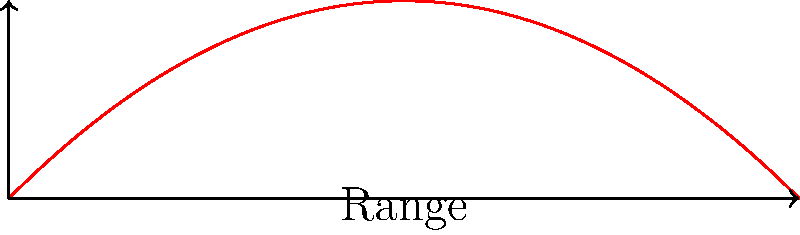In "The Hammer's Edge," Larry "Animal" Garner describes a scene where the protagonist throws a knife with an initial velocity of 20 m/s at a 45° angle. Using the provided diagram, calculate the maximum range of the thrown knife. Assume the knife is thrown from ground level and neglect air resistance. To solve this problem, we'll use the range formula for projectile motion:

1) The range formula is: $R = \frac{v_0^2 \sin(2\theta)}{g}$

   Where:
   $R$ is the range
   $v_0$ is the initial velocity
   $\theta$ is the launch angle
   $g$ is the acceleration due to gravity (9.8 m/s²)

2) We're given:
   $v_0 = 20$ m/s
   $\theta = 45°$
   $g = 9.8$ m/s²

3) First, let's calculate $\sin(2\theta)$:
   $\sin(2 \cdot 45°) = \sin(90°) = 1$

4) Now, let's substitute these values into the range formula:

   $R = \frac{20^2 \cdot 1}{9.8}$

5) Simplify:
   $R = \frac{400}{9.8} \approx 40.82$ m

Therefore, the maximum range of the thrown knife is approximately 40.82 meters.
Answer: 40.82 m 